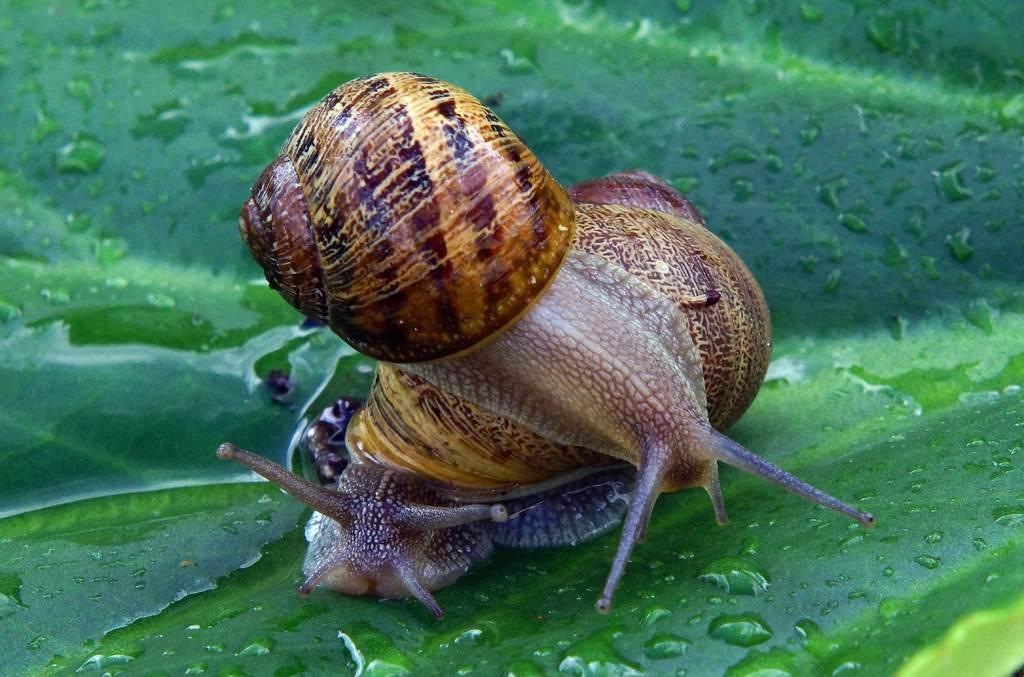What type of animal can be seen in the image? There is a snail in the image. What is the snail positioned on in the image? The snail is on a leaf in the image. Is there any liquid visible on the leaf? Yes, there is water on the leaf in the image. What type of fowl can be seen in the image? There is no fowl present in the image; it features a snail on a leaf with water. How loud is the image? The image is not loud, as it is a still image and does not have any audible components. 